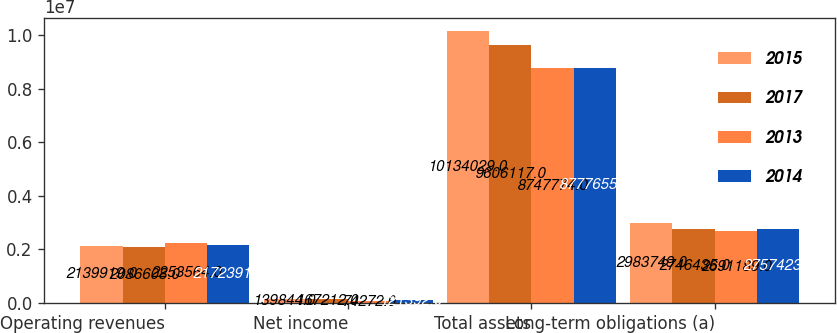Convert chart. <chart><loc_0><loc_0><loc_500><loc_500><stacked_bar_chart><ecel><fcel>Operating revenues<fcel>Net income<fcel>Total assets<fcel>Long-term obligations (a)<nl><fcel>2015<fcel>2.13992e+06<fcel>139844<fcel>1.0134e+07<fcel>2.98375e+06<nl><fcel>2017<fcel>2.08661e+06<fcel>167212<fcel>9.60612e+06<fcel>2.74644e+06<nl><fcel>2013<fcel>2.25356e+06<fcel>74272<fcel>8.74777e+06<fcel>2.69119e+06<nl><fcel>2014<fcel>2.17239e+06<fcel>121392<fcel>8.77766e+06<fcel>2.75742e+06<nl></chart> 